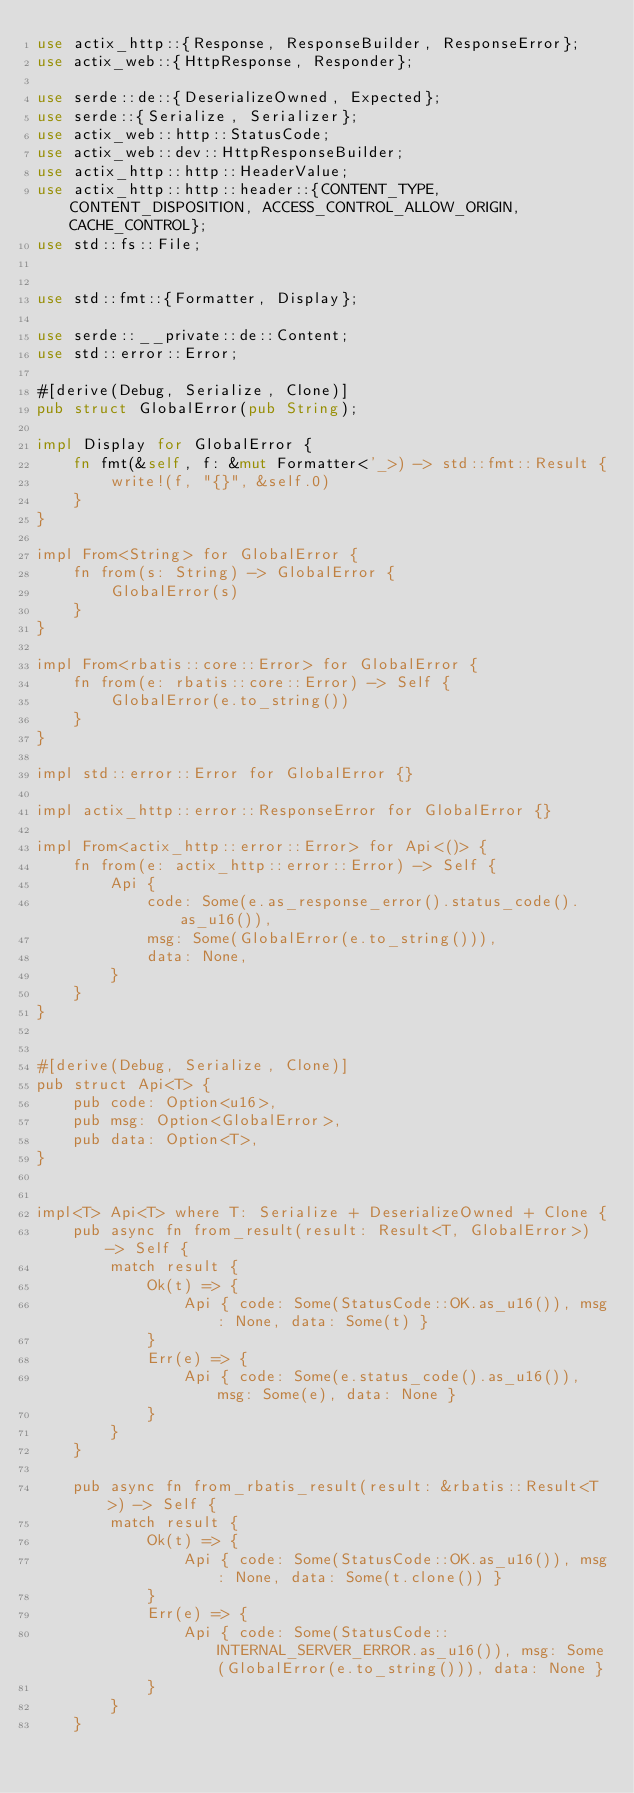<code> <loc_0><loc_0><loc_500><loc_500><_Rust_>use actix_http::{Response, ResponseBuilder, ResponseError};
use actix_web::{HttpResponse, Responder};

use serde::de::{DeserializeOwned, Expected};
use serde::{Serialize, Serializer};
use actix_web::http::StatusCode;
use actix_web::dev::HttpResponseBuilder;
use actix_http::http::HeaderValue;
use actix_http::http::header::{CONTENT_TYPE, CONTENT_DISPOSITION, ACCESS_CONTROL_ALLOW_ORIGIN, CACHE_CONTROL};
use std::fs::File;


use std::fmt::{Formatter, Display};

use serde::__private::de::Content;
use std::error::Error;

#[derive(Debug, Serialize, Clone)]
pub struct GlobalError(pub String);

impl Display for GlobalError {
    fn fmt(&self, f: &mut Formatter<'_>) -> std::fmt::Result {
        write!(f, "{}", &self.0)
    }
}

impl From<String> for GlobalError {
    fn from(s: String) -> GlobalError {
        GlobalError(s)
    }
}

impl From<rbatis::core::Error> for GlobalError {
    fn from(e: rbatis::core::Error) -> Self {
        GlobalError(e.to_string())
    }
}

impl std::error::Error for GlobalError {}

impl actix_http::error::ResponseError for GlobalError {}

impl From<actix_http::error::Error> for Api<()> {
    fn from(e: actix_http::error::Error) -> Self {
        Api {
            code: Some(e.as_response_error().status_code().as_u16()),
            msg: Some(GlobalError(e.to_string())),
            data: None,
        }
    }
}


#[derive(Debug, Serialize, Clone)]
pub struct Api<T> {
    pub code: Option<u16>,
    pub msg: Option<GlobalError>,
    pub data: Option<T>,
}


impl<T> Api<T> where T: Serialize + DeserializeOwned + Clone {
    pub async fn from_result(result: Result<T, GlobalError>) -> Self {
        match result {
            Ok(t) => {
                Api { code: Some(StatusCode::OK.as_u16()), msg: None, data: Some(t) }
            }
            Err(e) => {
                Api { code: Some(e.status_code().as_u16()), msg: Some(e), data: None }
            }
        }
    }

    pub async fn from_rbatis_result(result: &rbatis::Result<T>) -> Self {
        match result {
            Ok(t) => {
                Api { code: Some(StatusCode::OK.as_u16()), msg: None, data: Some(t.clone()) }
            }
            Err(e) => {
                Api { code: Some(StatusCode::INTERNAL_SERVER_ERROR.as_u16()), msg: Some(GlobalError(e.to_string())), data: None }
            }
        }
    }
</code> 